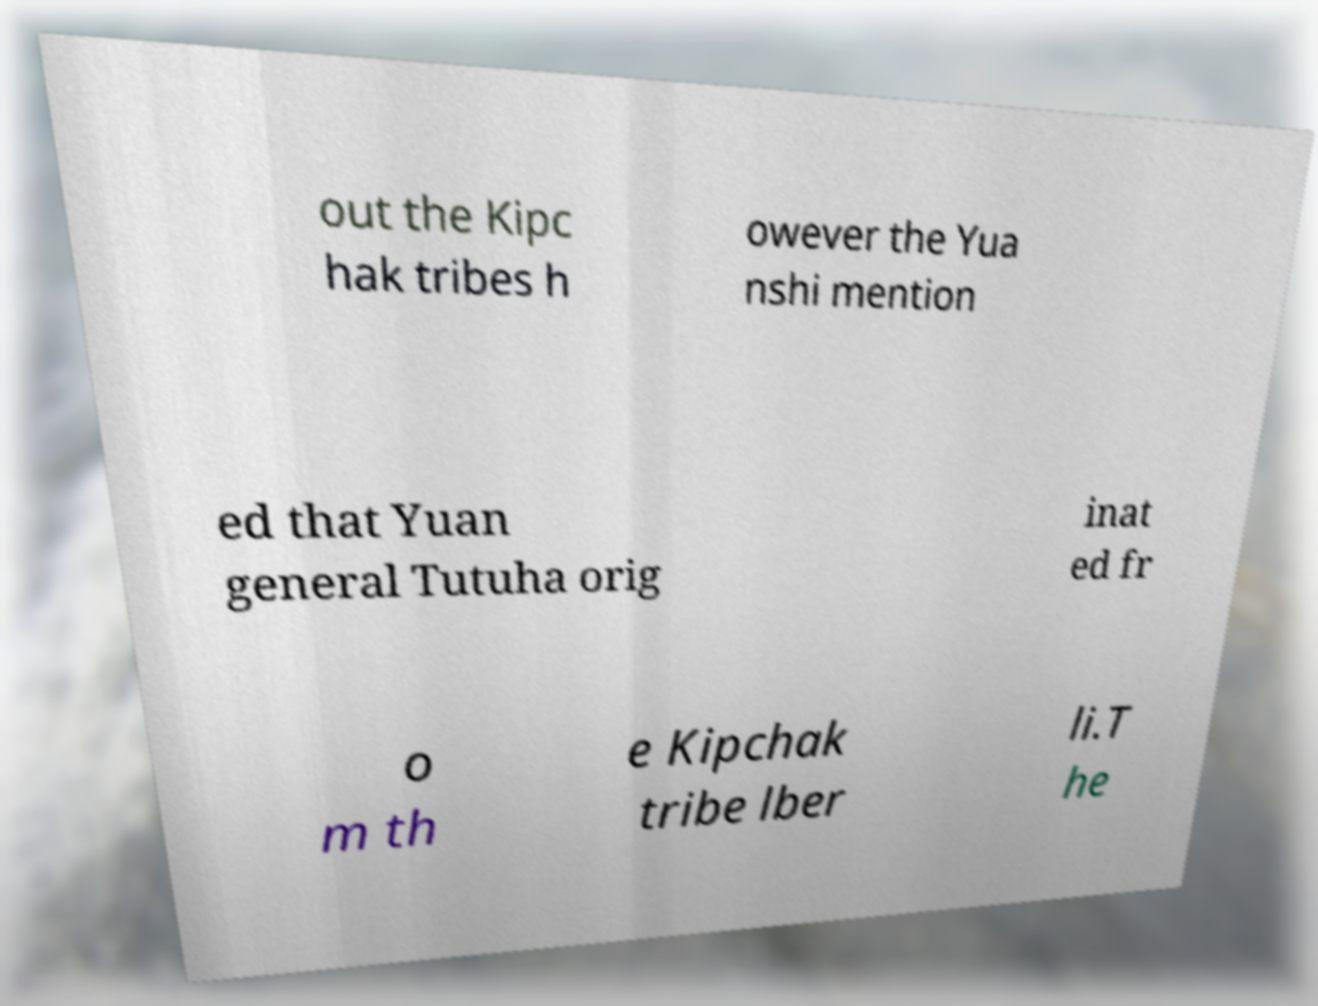I need the written content from this picture converted into text. Can you do that? out the Kipc hak tribes h owever the Yua nshi mention ed that Yuan general Tutuha orig inat ed fr o m th e Kipchak tribe lber li.T he 